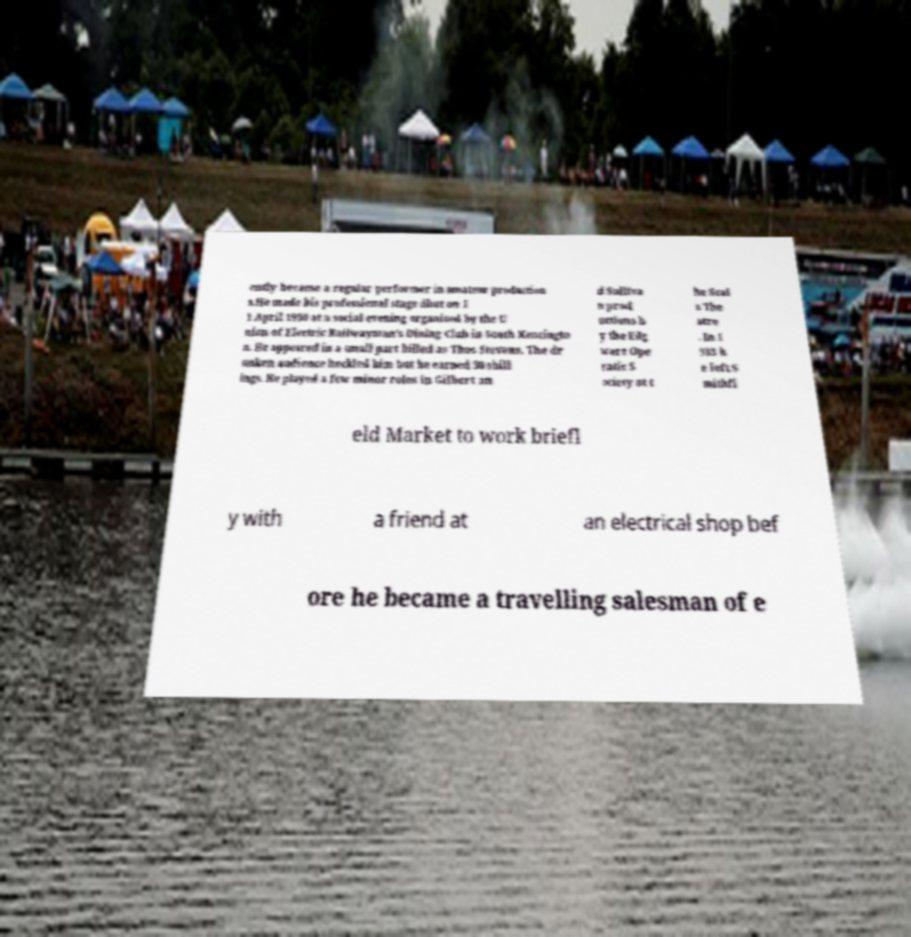Please identify and transcribe the text found in this image. ently became a regular performer in amateur production s.He made his professional stage dbut on 1 1 April 1930 at a social evening organised by the U nion of Electric Railwayman's Dining Club in South Kensingto n. He appeared in a small part billed as Thos Stevens. The dr unken audience heckled him but he earned 30 shill ings. He played a few minor roles in Gilbert an d Sulliva n prod uctions b y the Edg ware Ope ratic S ociety at t he Scal a The atre . In 1 933 h e left S mithfi eld Market to work briefl y with a friend at an electrical shop bef ore he became a travelling salesman of e 